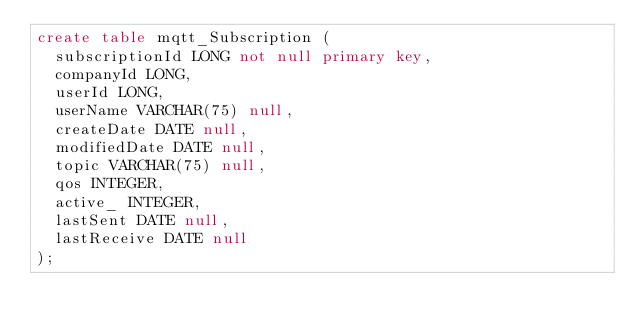Convert code to text. <code><loc_0><loc_0><loc_500><loc_500><_SQL_>create table mqtt_Subscription (
	subscriptionId LONG not null primary key,
	companyId LONG,
	userId LONG,
	userName VARCHAR(75) null,
	createDate DATE null,
	modifiedDate DATE null,
	topic VARCHAR(75) null,
	qos INTEGER,
	active_ INTEGER,
	lastSent DATE null,
	lastReceive DATE null
);</code> 